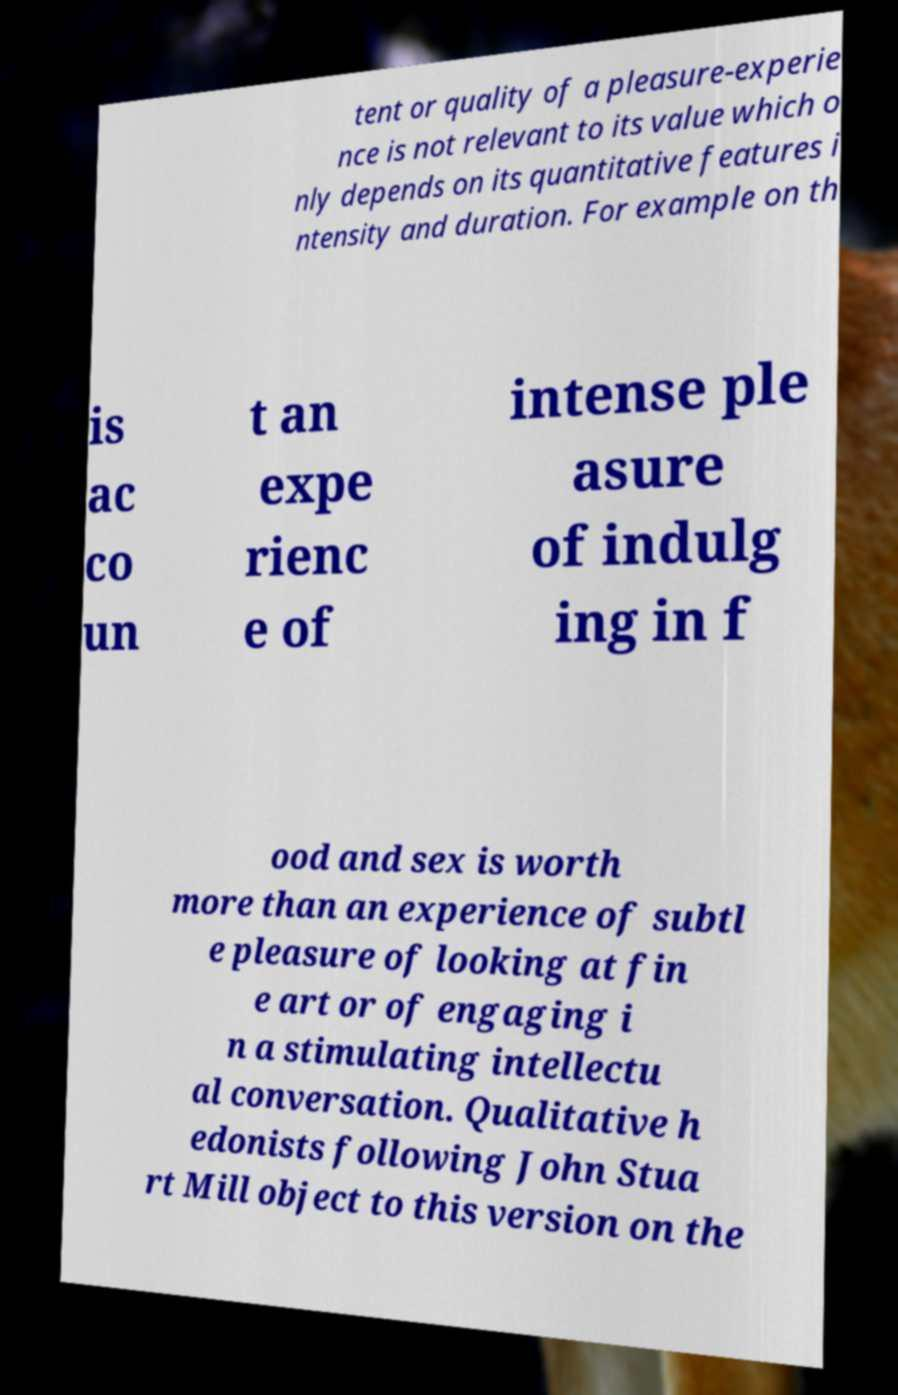What messages or text are displayed in this image? I need them in a readable, typed format. tent or quality of a pleasure-experie nce is not relevant to its value which o nly depends on its quantitative features i ntensity and duration. For example on th is ac co un t an expe rienc e of intense ple asure of indulg ing in f ood and sex is worth more than an experience of subtl e pleasure of looking at fin e art or of engaging i n a stimulating intellectu al conversation. Qualitative h edonists following John Stua rt Mill object to this version on the 